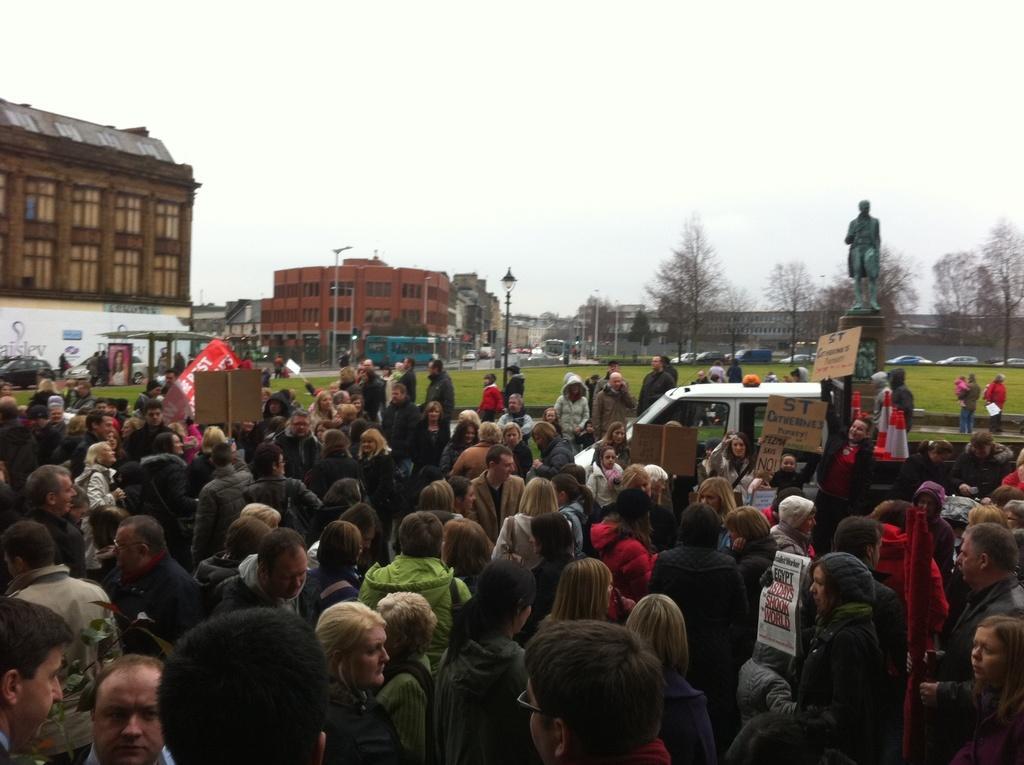Describe this image in one or two sentences. In this image we can see group of persons standing in the ground holding cards in their hands. In the background, we can see a car parked on the road, a group of buildings, trees, a statue and the sky. 